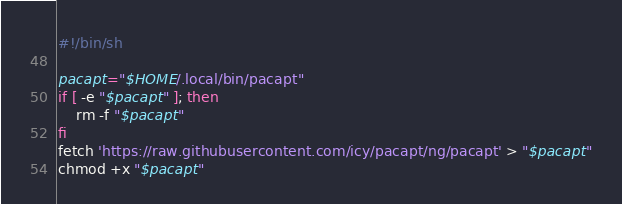Convert code to text. <code><loc_0><loc_0><loc_500><loc_500><_Bash_>#!/bin/sh

pacapt="$HOME/.local/bin/pacapt"
if [ -e "$pacapt" ]; then
    rm -f "$pacapt"
fi
fetch 'https://raw.githubusercontent.com/icy/pacapt/ng/pacapt' > "$pacapt"
chmod +x "$pacapt"</code> 